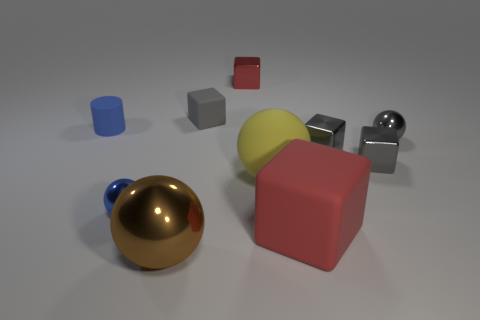There is a blue object that is the same shape as the brown shiny thing; what is its size?
Your answer should be very brief. Small. There is a red block in front of the small red thing; is its size the same as the shiny sphere that is behind the small blue metal thing?
Give a very brief answer. No. Is there anything else that has the same material as the large red thing?
Provide a short and direct response. Yes. What number of objects are either shiny spheres that are to the right of the small red thing or metal objects in front of the small rubber block?
Make the answer very short. 5. Do the gray sphere and the sphere that is to the left of the brown object have the same material?
Ensure brevity in your answer.  Yes. There is a metallic object that is both to the left of the large red cube and behind the small blue shiny thing; what shape is it?
Give a very brief answer. Cube. What number of other objects are there of the same color as the large matte block?
Offer a terse response. 1. The yellow rubber thing has what shape?
Your answer should be compact. Sphere. There is a small sphere that is to the right of the red block behind the gray ball; what is its color?
Offer a very short reply. Gray. Does the big metallic sphere have the same color as the matte thing that is behind the small blue cylinder?
Provide a short and direct response. No. 